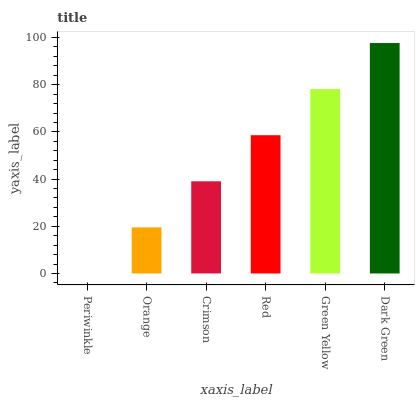Is Periwinkle the minimum?
Answer yes or no. Yes. Is Dark Green the maximum?
Answer yes or no. Yes. Is Orange the minimum?
Answer yes or no. No. Is Orange the maximum?
Answer yes or no. No. Is Orange greater than Periwinkle?
Answer yes or no. Yes. Is Periwinkle less than Orange?
Answer yes or no. Yes. Is Periwinkle greater than Orange?
Answer yes or no. No. Is Orange less than Periwinkle?
Answer yes or no. No. Is Red the high median?
Answer yes or no. Yes. Is Crimson the low median?
Answer yes or no. Yes. Is Green Yellow the high median?
Answer yes or no. No. Is Green Yellow the low median?
Answer yes or no. No. 